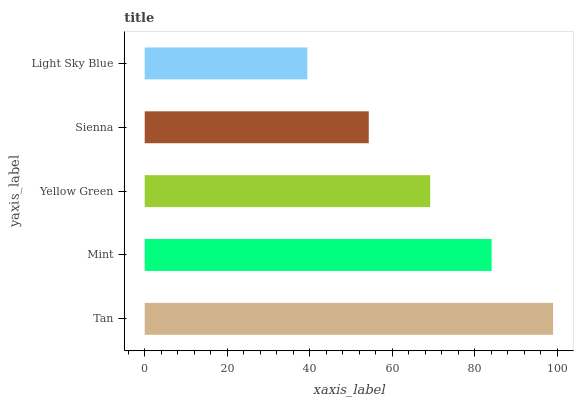Is Light Sky Blue the minimum?
Answer yes or no. Yes. Is Tan the maximum?
Answer yes or no. Yes. Is Mint the minimum?
Answer yes or no. No. Is Mint the maximum?
Answer yes or no. No. Is Tan greater than Mint?
Answer yes or no. Yes. Is Mint less than Tan?
Answer yes or no. Yes. Is Mint greater than Tan?
Answer yes or no. No. Is Tan less than Mint?
Answer yes or no. No. Is Yellow Green the high median?
Answer yes or no. Yes. Is Yellow Green the low median?
Answer yes or no. Yes. Is Light Sky Blue the high median?
Answer yes or no. No. Is Sienna the low median?
Answer yes or no. No. 